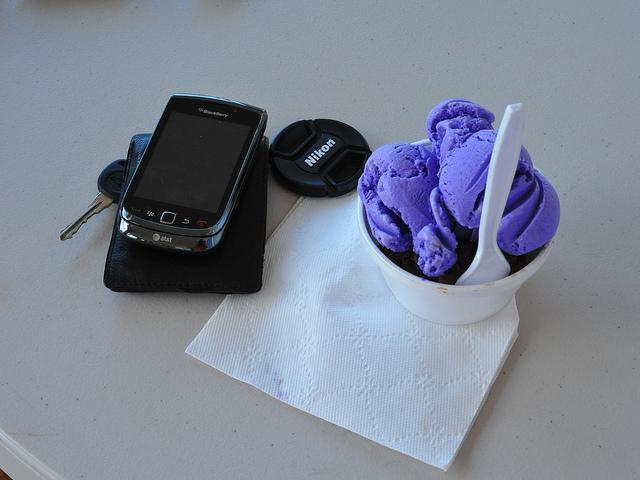How many bowls are in the photo?
Give a very brief answer. 1. How many bunches of bananas are there?
Give a very brief answer. 0. 